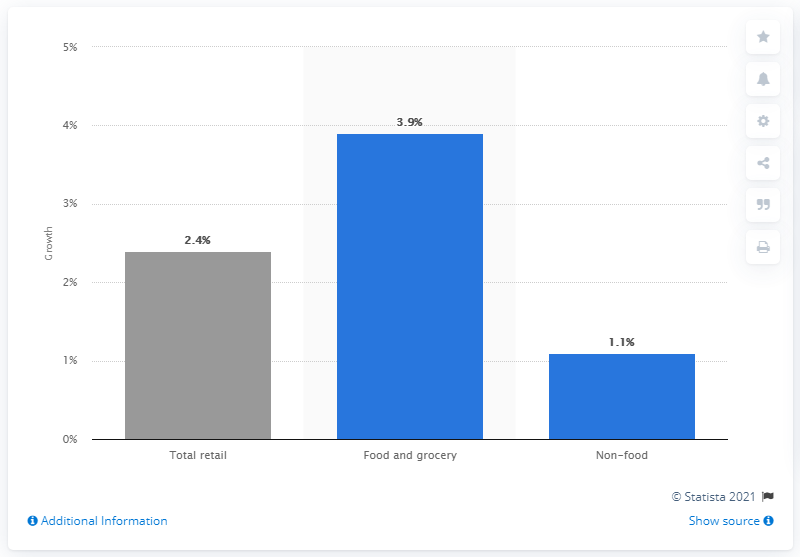Identify some key points in this picture. According to the forecast, the food and grocery sector is expected to grow the most out of all the food and non-food sectors, at a rate of 3.9%. The forecasted growth in retail expenditure in the UK from 2013 to 2014 was 2.4%. 